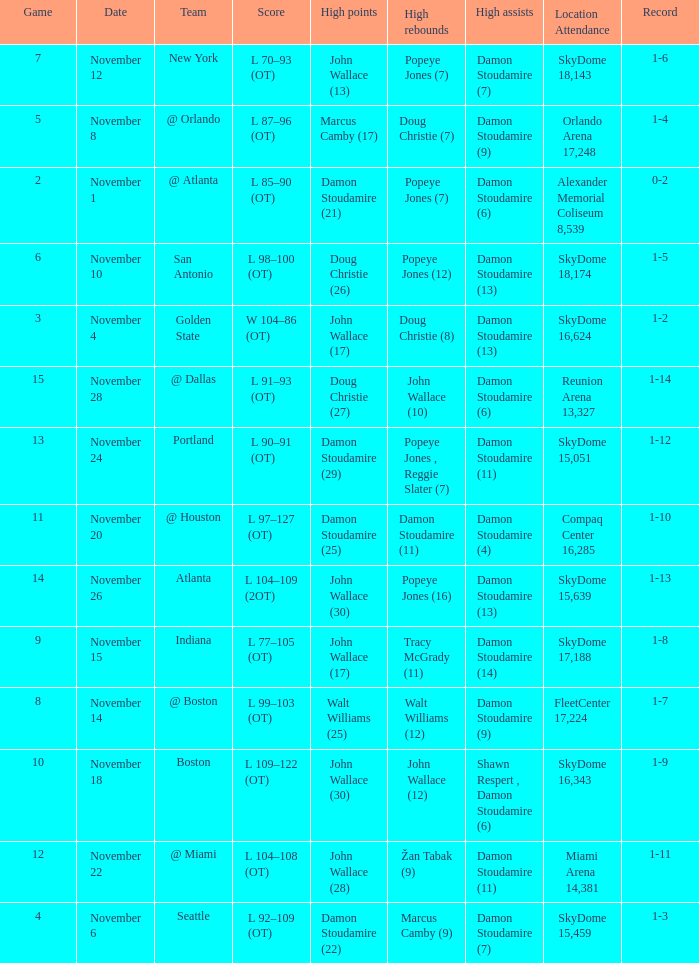What was the score against san antonio? L 98–100 (OT). 